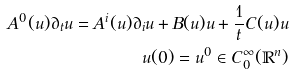Convert formula to latex. <formula><loc_0><loc_0><loc_500><loc_500>A ^ { 0 } ( u ) \partial _ { t } u = A ^ { i } ( u ) \partial _ { i } u + B ( u ) u + \frac { 1 } { t } C ( u ) u \\ u ( 0 ) = u ^ { 0 } \in C _ { 0 } ^ { \infty } ( \mathbb { R } ^ { n } )</formula> 